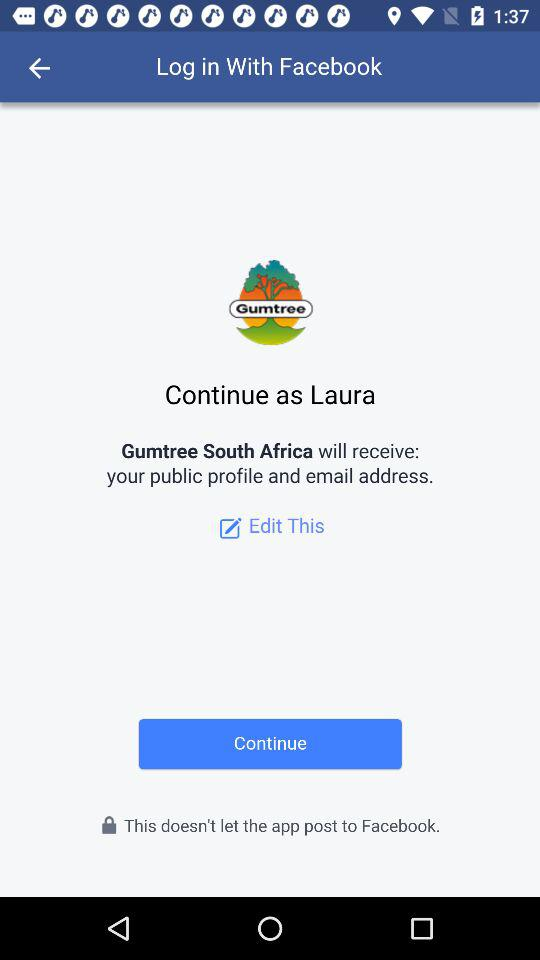What is the name of the user? The name of the user is "Laura". 